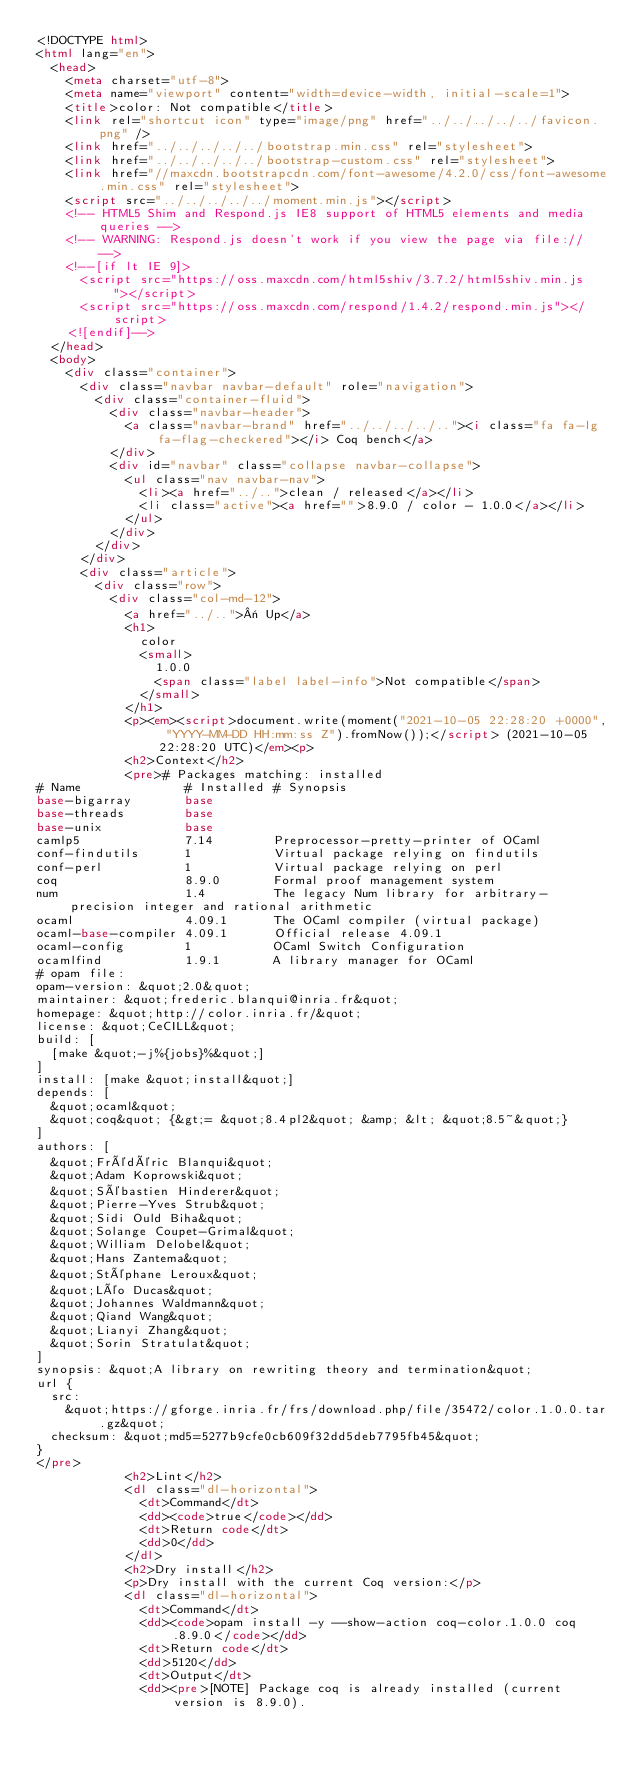Convert code to text. <code><loc_0><loc_0><loc_500><loc_500><_HTML_><!DOCTYPE html>
<html lang="en">
  <head>
    <meta charset="utf-8">
    <meta name="viewport" content="width=device-width, initial-scale=1">
    <title>color: Not compatible</title>
    <link rel="shortcut icon" type="image/png" href="../../../../../favicon.png" />
    <link href="../../../../../bootstrap.min.css" rel="stylesheet">
    <link href="../../../../../bootstrap-custom.css" rel="stylesheet">
    <link href="//maxcdn.bootstrapcdn.com/font-awesome/4.2.0/css/font-awesome.min.css" rel="stylesheet">
    <script src="../../../../../moment.min.js"></script>
    <!-- HTML5 Shim and Respond.js IE8 support of HTML5 elements and media queries -->
    <!-- WARNING: Respond.js doesn't work if you view the page via file:// -->
    <!--[if lt IE 9]>
      <script src="https://oss.maxcdn.com/html5shiv/3.7.2/html5shiv.min.js"></script>
      <script src="https://oss.maxcdn.com/respond/1.4.2/respond.min.js"></script>
    <![endif]-->
  </head>
  <body>
    <div class="container">
      <div class="navbar navbar-default" role="navigation">
        <div class="container-fluid">
          <div class="navbar-header">
            <a class="navbar-brand" href="../../../../.."><i class="fa fa-lg fa-flag-checkered"></i> Coq bench</a>
          </div>
          <div id="navbar" class="collapse navbar-collapse">
            <ul class="nav navbar-nav">
              <li><a href="../..">clean / released</a></li>
              <li class="active"><a href="">8.9.0 / color - 1.0.0</a></li>
            </ul>
          </div>
        </div>
      </div>
      <div class="article">
        <div class="row">
          <div class="col-md-12">
            <a href="../..">« Up</a>
            <h1>
              color
              <small>
                1.0.0
                <span class="label label-info">Not compatible</span>
              </small>
            </h1>
            <p><em><script>document.write(moment("2021-10-05 22:28:20 +0000", "YYYY-MM-DD HH:mm:ss Z").fromNow());</script> (2021-10-05 22:28:20 UTC)</em><p>
            <h2>Context</h2>
            <pre># Packages matching: installed
# Name              # Installed # Synopsis
base-bigarray       base
base-threads        base
base-unix           base
camlp5              7.14        Preprocessor-pretty-printer of OCaml
conf-findutils      1           Virtual package relying on findutils
conf-perl           1           Virtual package relying on perl
coq                 8.9.0       Formal proof management system
num                 1.4         The legacy Num library for arbitrary-precision integer and rational arithmetic
ocaml               4.09.1      The OCaml compiler (virtual package)
ocaml-base-compiler 4.09.1      Official release 4.09.1
ocaml-config        1           OCaml Switch Configuration
ocamlfind           1.9.1       A library manager for OCaml
# opam file:
opam-version: &quot;2.0&quot;
maintainer: &quot;frederic.blanqui@inria.fr&quot;
homepage: &quot;http://color.inria.fr/&quot;
license: &quot;CeCILL&quot;
build: [
  [make &quot;-j%{jobs}%&quot;]
]
install: [make &quot;install&quot;]
depends: [
  &quot;ocaml&quot;
  &quot;coq&quot; {&gt;= &quot;8.4pl2&quot; &amp; &lt; &quot;8.5~&quot;}
]
authors: [
  &quot;Frédéric Blanqui&quot;
  &quot;Adam Koprowski&quot;
  &quot;Sébastien Hinderer&quot;
  &quot;Pierre-Yves Strub&quot;
  &quot;Sidi Ould Biha&quot;
  &quot;Solange Coupet-Grimal&quot;
  &quot;William Delobel&quot;
  &quot;Hans Zantema&quot;
  &quot;Stéphane Leroux&quot;
  &quot;Léo Ducas&quot;
  &quot;Johannes Waldmann&quot;
  &quot;Qiand Wang&quot;
  &quot;Lianyi Zhang&quot;
  &quot;Sorin Stratulat&quot;
]
synopsis: &quot;A library on rewriting theory and termination&quot;
url {
  src:
    &quot;https://gforge.inria.fr/frs/download.php/file/35472/color.1.0.0.tar.gz&quot;
  checksum: &quot;md5=5277b9cfe0cb609f32dd5deb7795fb45&quot;
}
</pre>
            <h2>Lint</h2>
            <dl class="dl-horizontal">
              <dt>Command</dt>
              <dd><code>true</code></dd>
              <dt>Return code</dt>
              <dd>0</dd>
            </dl>
            <h2>Dry install</h2>
            <p>Dry install with the current Coq version:</p>
            <dl class="dl-horizontal">
              <dt>Command</dt>
              <dd><code>opam install -y --show-action coq-color.1.0.0 coq.8.9.0</code></dd>
              <dt>Return code</dt>
              <dd>5120</dd>
              <dt>Output</dt>
              <dd><pre>[NOTE] Package coq is already installed (current version is 8.9.0).</code> 